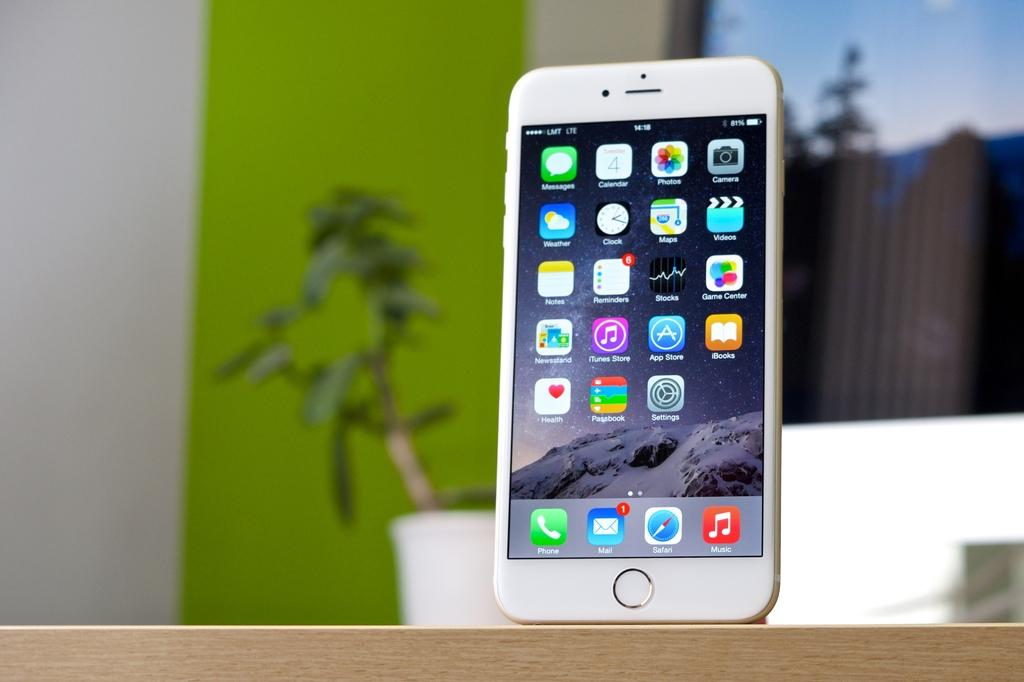Provide a one-sentence caption for the provided image. A cell phone display shows that there is one unread email message. 